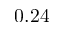Convert formula to latex. <formula><loc_0><loc_0><loc_500><loc_500>0 . 2 4</formula> 